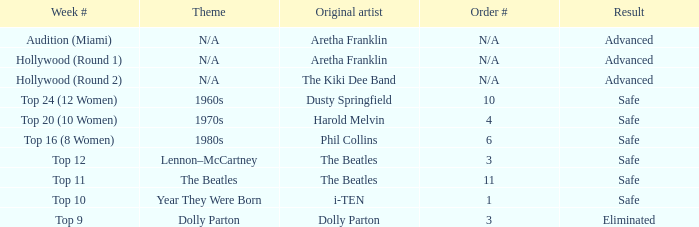What is the original artist of top 9 as the week number? Dolly Parton. 